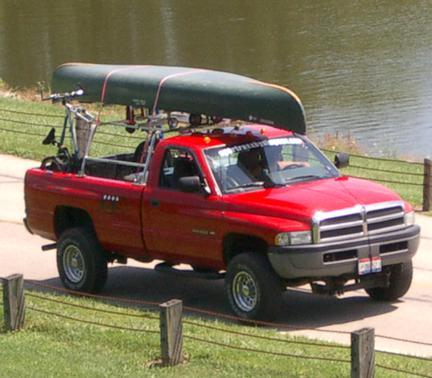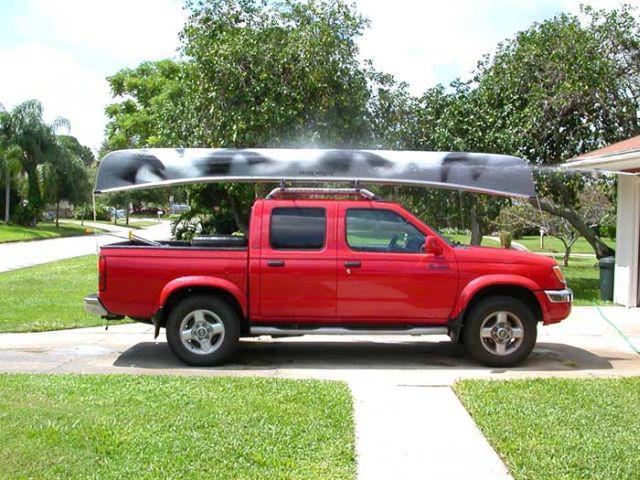The first image is the image on the left, the second image is the image on the right. Examine the images to the left and right. Is the description "A body of water is visible behind a truck" accurate? Answer yes or no. Yes. 